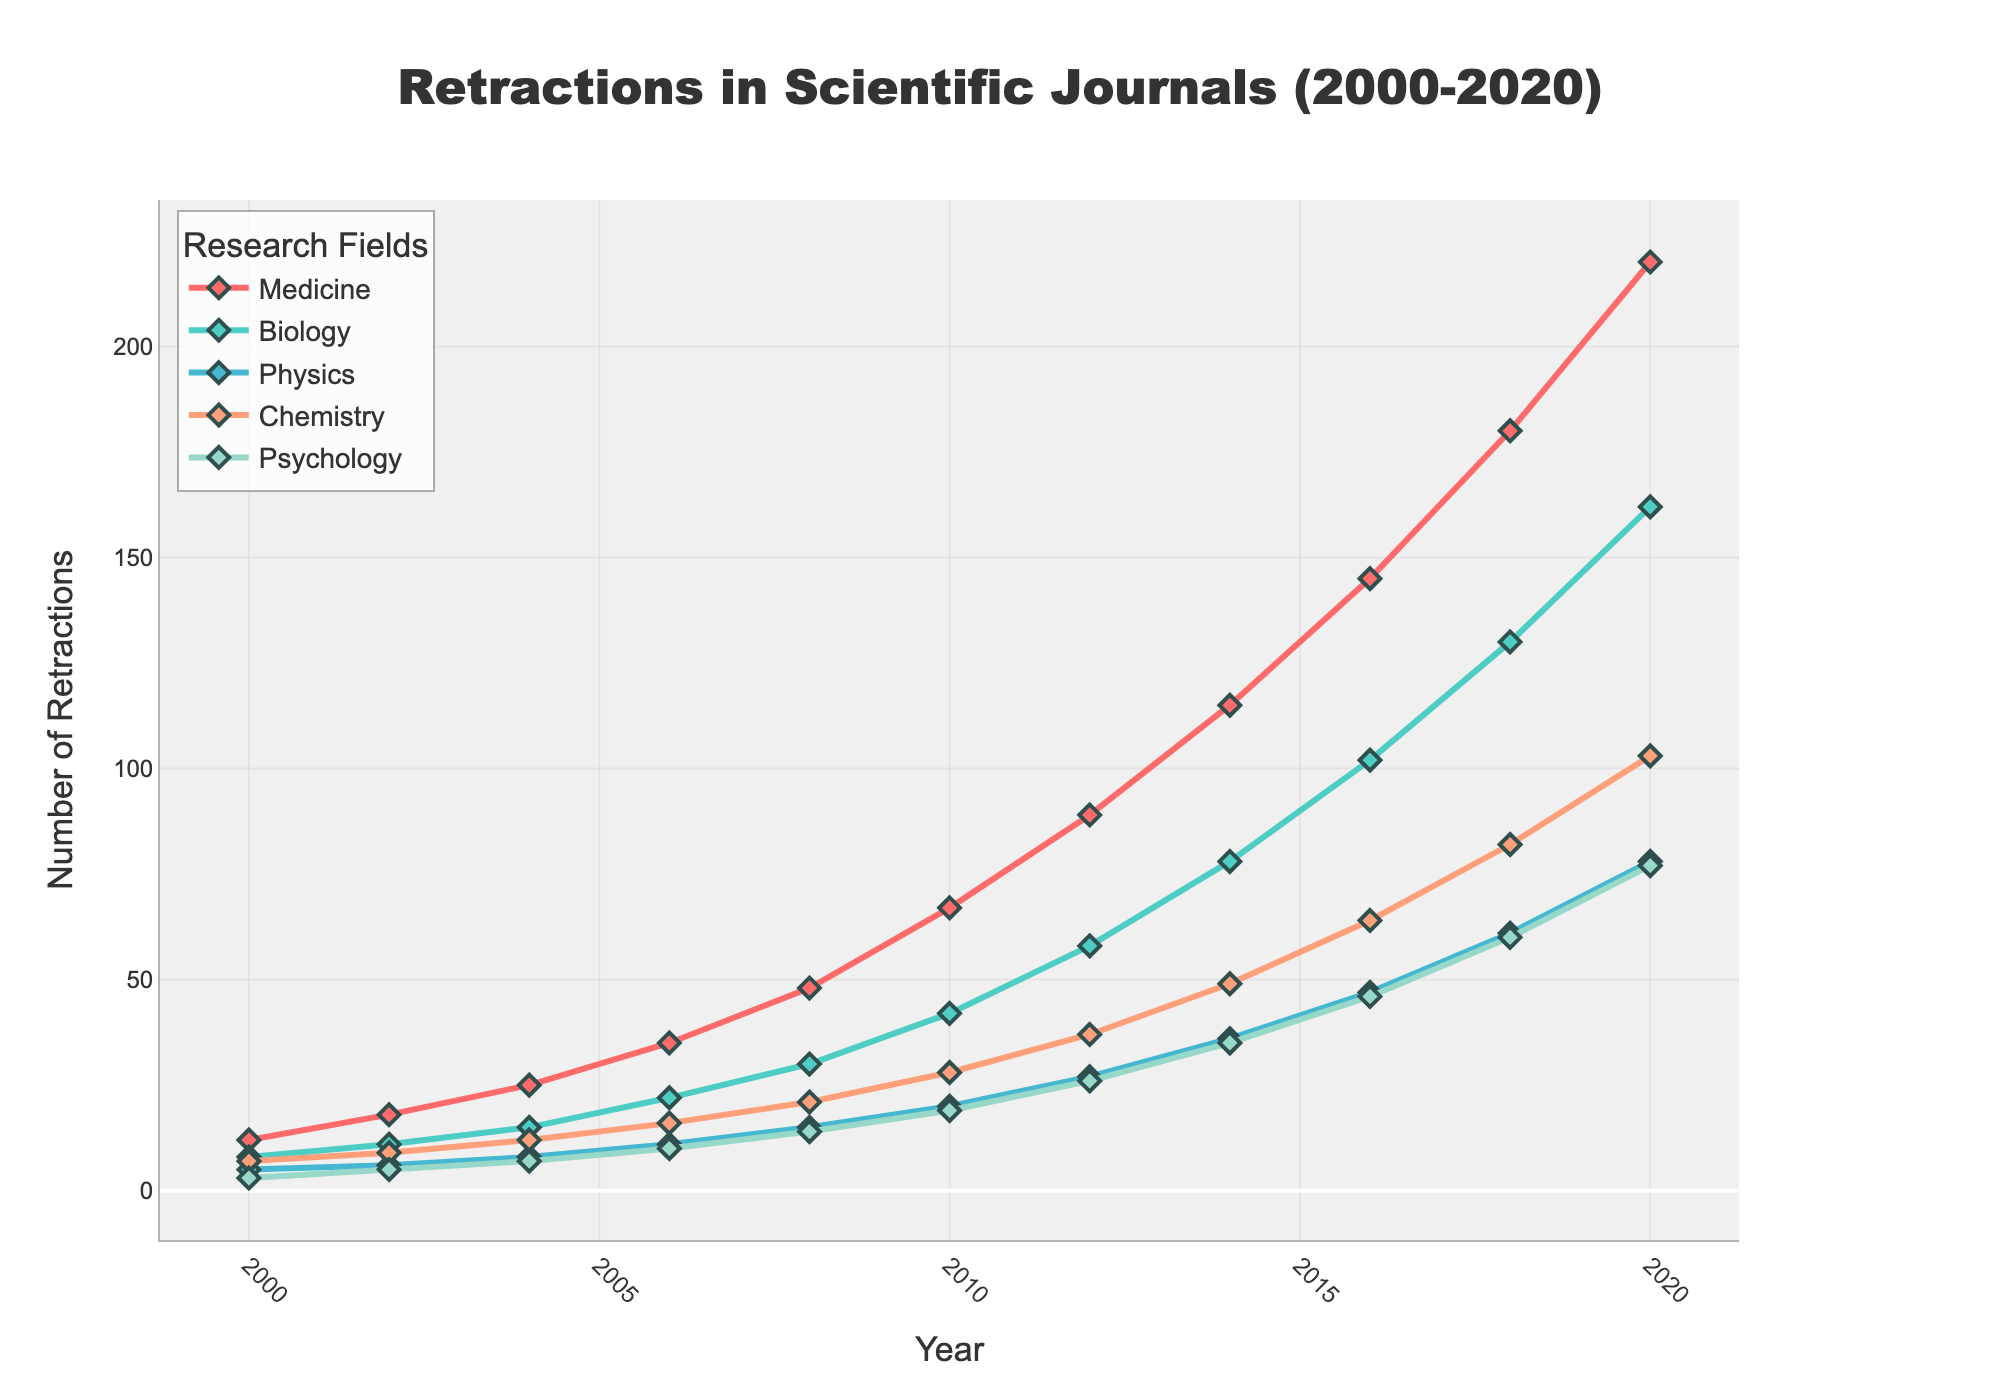What is the overall trend in the number of retractions in the field of Medicine from 2000 to 2020? By examining the plotted line for Medicine (red), one can see a steady increase in the number of retractions from 2000 to 2020. The count starts at 12 in 2000 and rises significantly to 220 by 2020. Thus, the overall trend shows a substantial upward trajectory.
Answer: Steady increase Which research field had the highest number of retractions in 2020? To determine this, look at the endpoints of each research field's line plot for the year 2020. The red line representing Medicine is the highest at 220 retractions.
Answer: Medicine How does the trend in the number of retractions in Physics compare to Biology from 2000 to 2020? The Physics trend line (blue) rises from 5 in 2000 to 78 in 2020. The Biology trend line (green) starts at 8 in 2000 and rises to 162 in 2020. Biology experienced a larger increase in retractions compared to Physics over the same period.
Answer: Biology increased more What year did Chemistry first exceed 50 retractions? By observing the line for Chemistry (orange), it surpasses 50 retractions between 2014 and 2016, with the exact year being 2016.
Answer: 2016 What is the difference in the number of retractions between Psychology and Biology in 2014? The number of retractions in 2014 for Psychology is 35, and for Biology, it is 78. The difference is 78 - 35 = 43.
Answer: 43 In what year did the number of retractions in Medicine and Chemistry both exceed 100? Examining the trends, 2016 is the first year both lines (Medicine in red and Chemistry in orange) exceed 100, with Medicine at 145 and Chemistry at 103.
Answer: 2016 